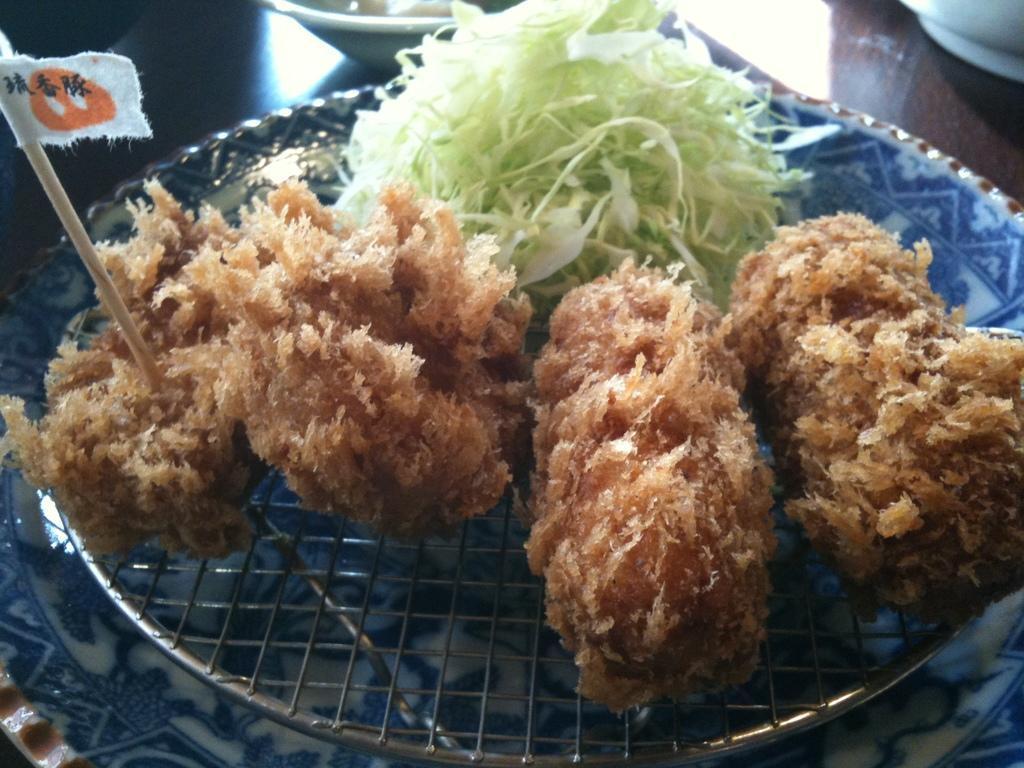How would you summarize this image in a sentence or two? In this picture there is a food item and chopped cabbage in the image. 